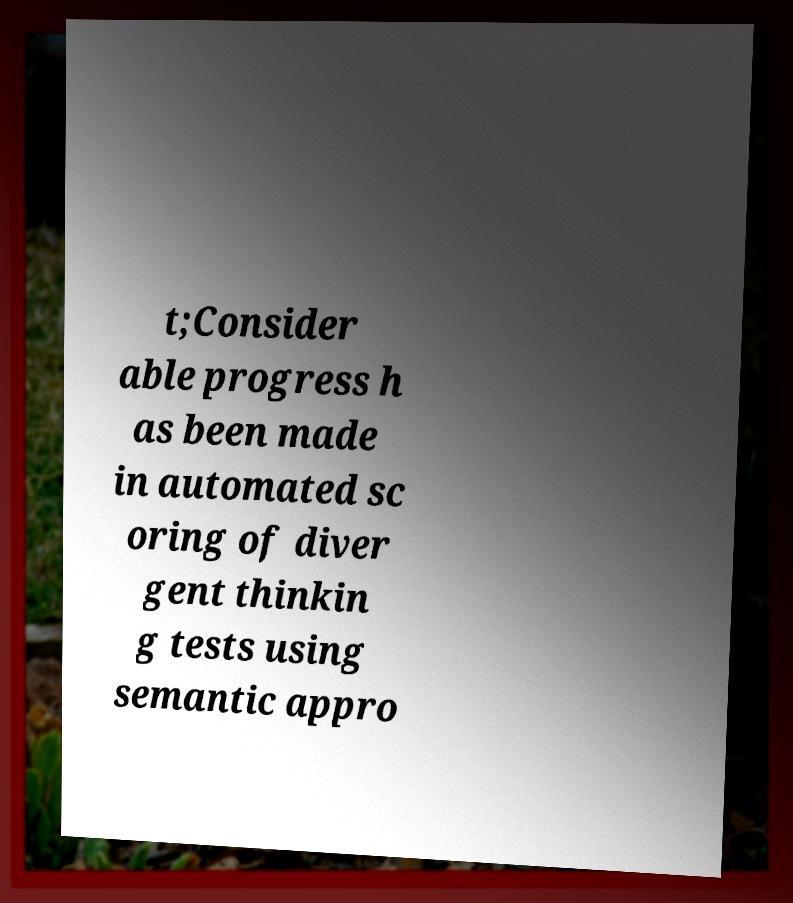I need the written content from this picture converted into text. Can you do that? t;Consider able progress h as been made in automated sc oring of diver gent thinkin g tests using semantic appro 